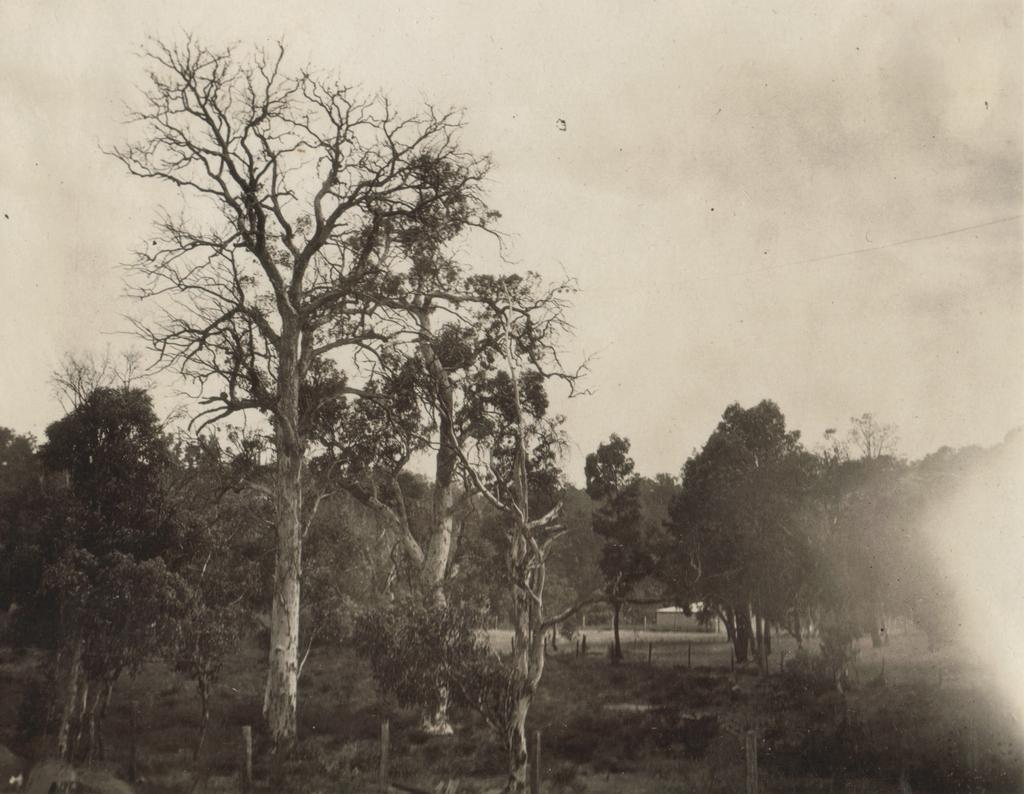What type of vegetation is predominant in the image? There are many trees in the image. What is the ground cover around the trees? There is grass around the trees in the image. Can you see any jellyfish swimming in the harbor in the image? There is no harbor or jellyfish present in the image; it features trees and grass. 